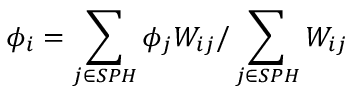Convert formula to latex. <formula><loc_0><loc_0><loc_500><loc_500>\phi _ { i } = \sum _ { j \in S P H } \phi _ { j } W _ { i j } / \sum _ { j \in S P H } W _ { i j }</formula> 